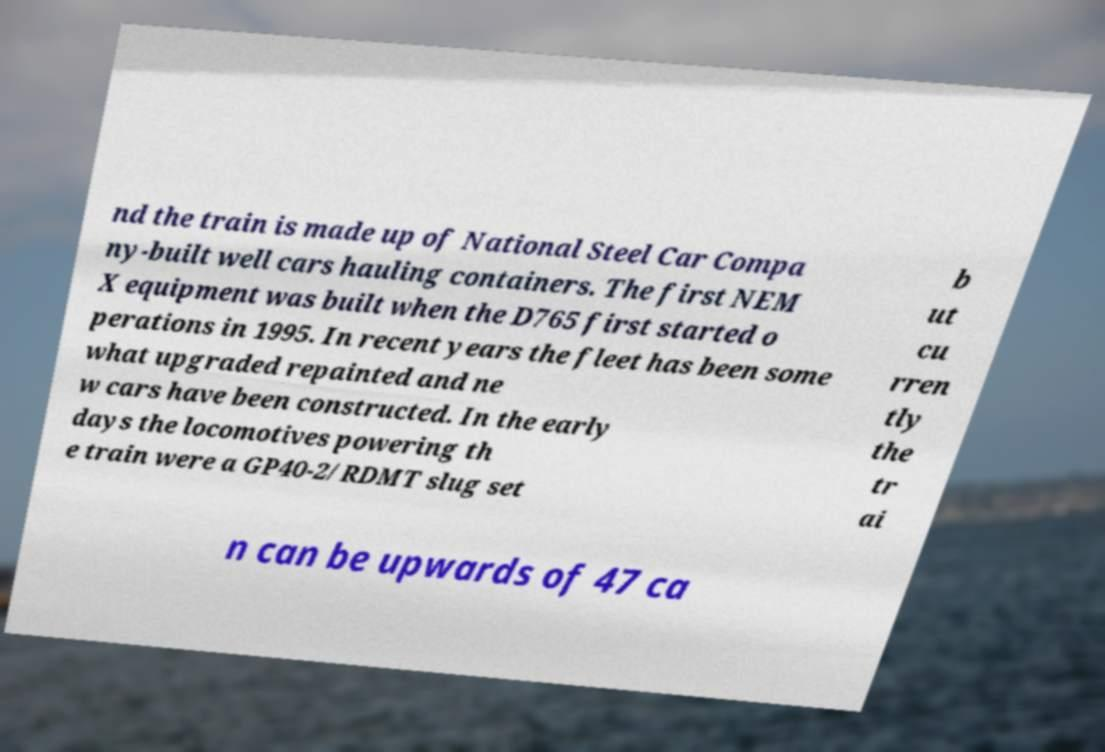Can you read and provide the text displayed in the image?This photo seems to have some interesting text. Can you extract and type it out for me? nd the train is made up of National Steel Car Compa ny-built well cars hauling containers. The first NEM X equipment was built when the D765 first started o perations in 1995. In recent years the fleet has been some what upgraded repainted and ne w cars have been constructed. In the early days the locomotives powering th e train were a GP40-2/RDMT slug set b ut cu rren tly the tr ai n can be upwards of 47 ca 